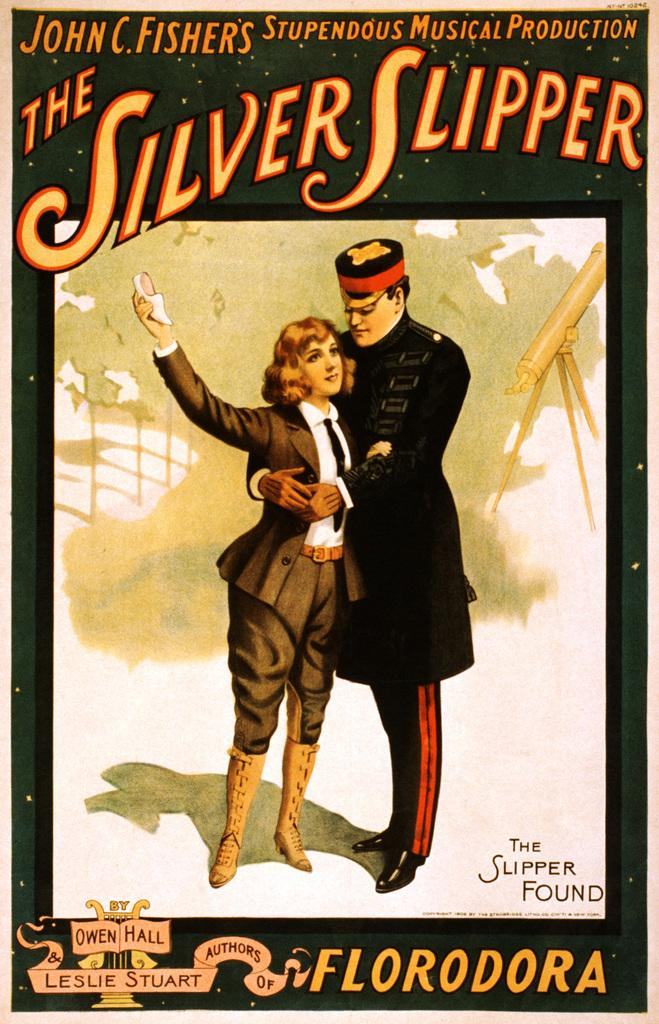<image>
Write a terse but informative summary of the picture. A poster promotes the musical production of The Silver Slipper. 